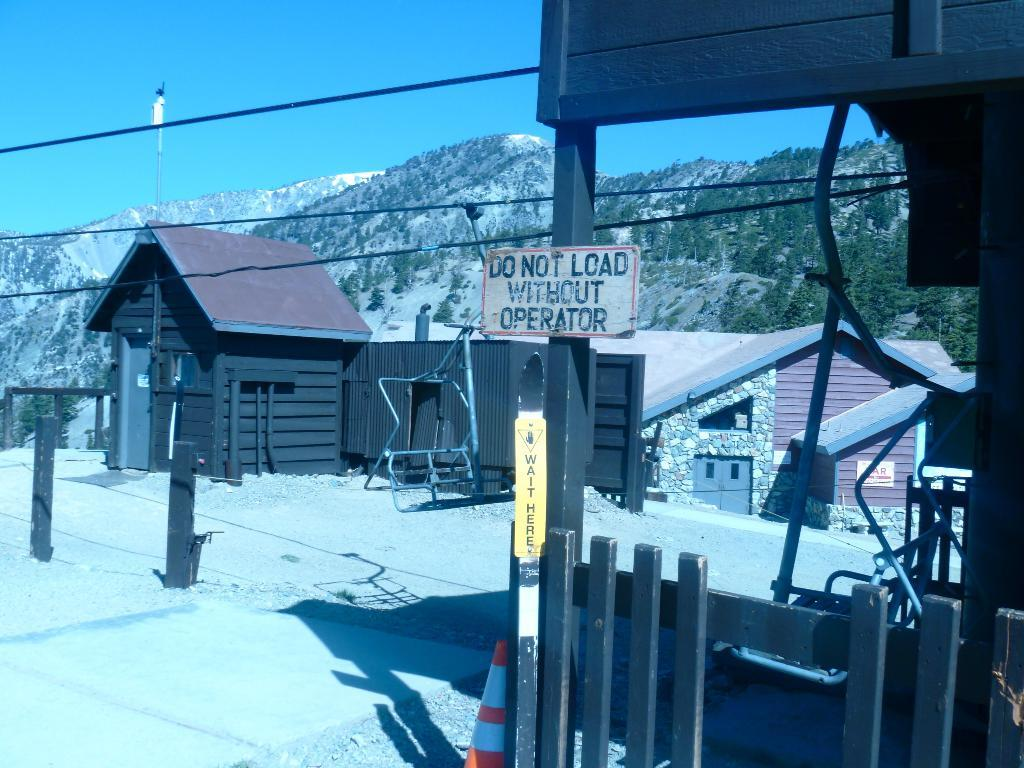What can be seen in the center of the image? The sky is visible in the center of the image. What type of natural features are present in the image? There are hills and trees in the image. What type of man-made structures can be seen in the image? There are buildings, poles, and a traffic pole in the image. What type of objects are present in the image that may have text or information on them? Boards with text are in the image. Are there any other objects or features in the image that have not been mentioned yet? Yes, there are other objects in the image. Can you see any animals on a farm in the image? There is no farm or animals present in the image. How does the traffic pole move around in the image? The traffic pole does not move around in the image; it is stationary. 